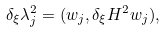Convert formula to latex. <formula><loc_0><loc_0><loc_500><loc_500>\delta _ { \xi } \lambda _ { j } ^ { 2 } = ( w _ { j } , \delta _ { \xi } H ^ { 2 } w _ { j } ) ,</formula> 